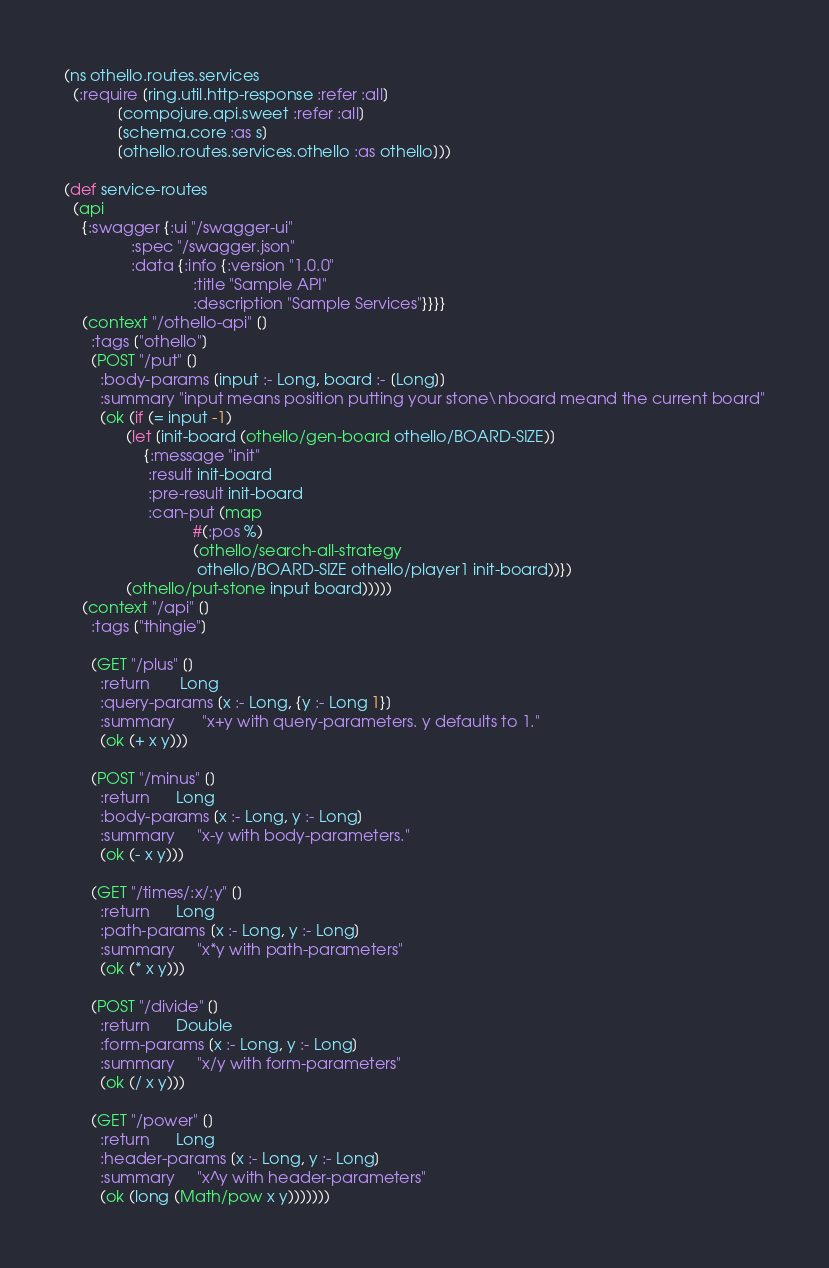Convert code to text. <code><loc_0><loc_0><loc_500><loc_500><_Clojure_>(ns othello.routes.services
  (:require [ring.util.http-response :refer :all]
            [compojure.api.sweet :refer :all]
            [schema.core :as s]
            [othello.routes.services.othello :as othello]))

(def service-routes
  (api
    {:swagger {:ui "/swagger-ui"
               :spec "/swagger.json"
               :data {:info {:version "1.0.0"
                             :title "Sample API"
                             :description "Sample Services"}}}}
    (context "/othello-api" []
      :tags ["othello"]
      (POST "/put" []
        :body-params [input :- Long, board :- [Long]]
        :summary "input means position putting your stone\nboard meand the current board"
        (ok (if (= input -1)
              (let [init-board (othello/gen-board othello/BOARD-SIZE)]
                  {:message "init"
                   :result init-board
                   :pre-result init-board
                   :can-put (map
                             #(:pos %)
                             (othello/search-all-strategy
                              othello/BOARD-SIZE othello/player1 init-board))})
              (othello/put-stone input board)))))
    (context "/api" []
      :tags ["thingie"]
      
      (GET "/plus" []
        :return       Long
        :query-params [x :- Long, {y :- Long 1}]
        :summary      "x+y with query-parameters. y defaults to 1."
        (ok (+ x y)))

      (POST "/minus" []
        :return      Long
        :body-params [x :- Long, y :- Long]
        :summary     "x-y with body-parameters."
        (ok (- x y)))

      (GET "/times/:x/:y" []
        :return      Long
        :path-params [x :- Long, y :- Long]
        :summary     "x*y with path-parameters"
        (ok (* x y)))

      (POST "/divide" []
        :return      Double
        :form-params [x :- Long, y :- Long]
        :summary     "x/y with form-parameters"
        (ok (/ x y)))

      (GET "/power" []
        :return      Long
        :header-params [x :- Long, y :- Long]
        :summary     "x^y with header-parameters"
        (ok (long (Math/pow x y)))))))
</code> 